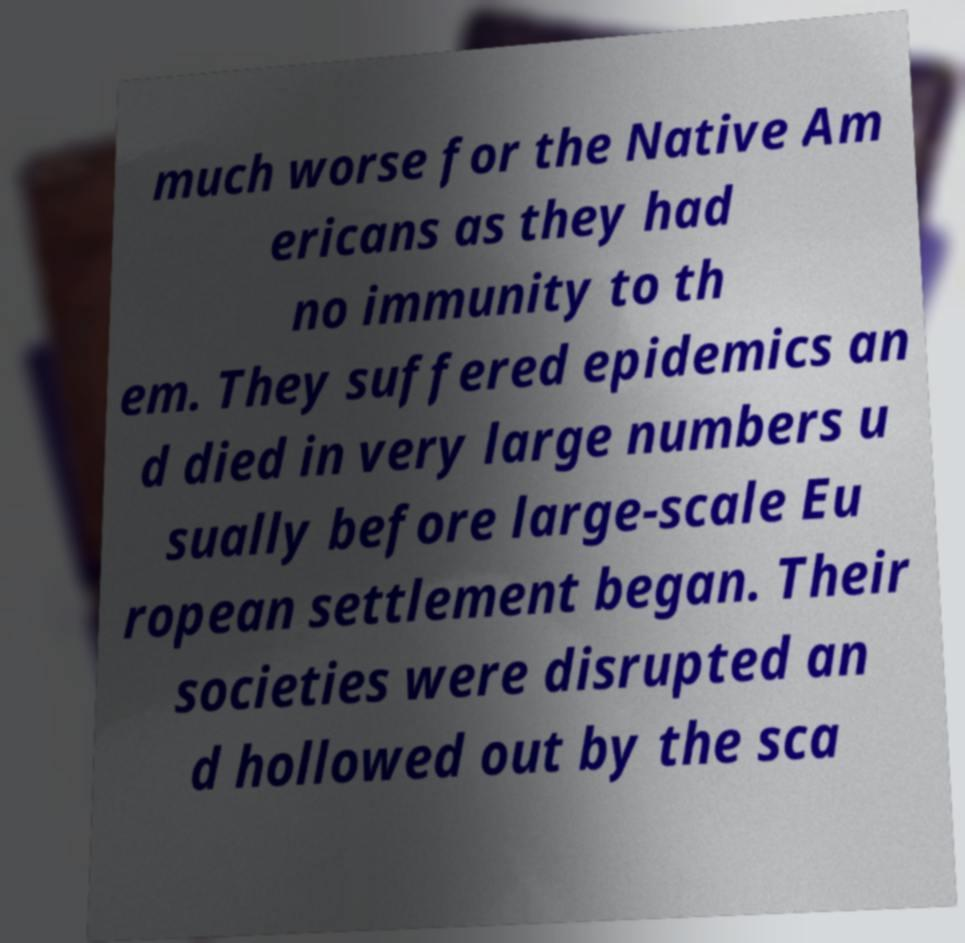Could you extract and type out the text from this image? much worse for the Native Am ericans as they had no immunity to th em. They suffered epidemics an d died in very large numbers u sually before large-scale Eu ropean settlement began. Their societies were disrupted an d hollowed out by the sca 